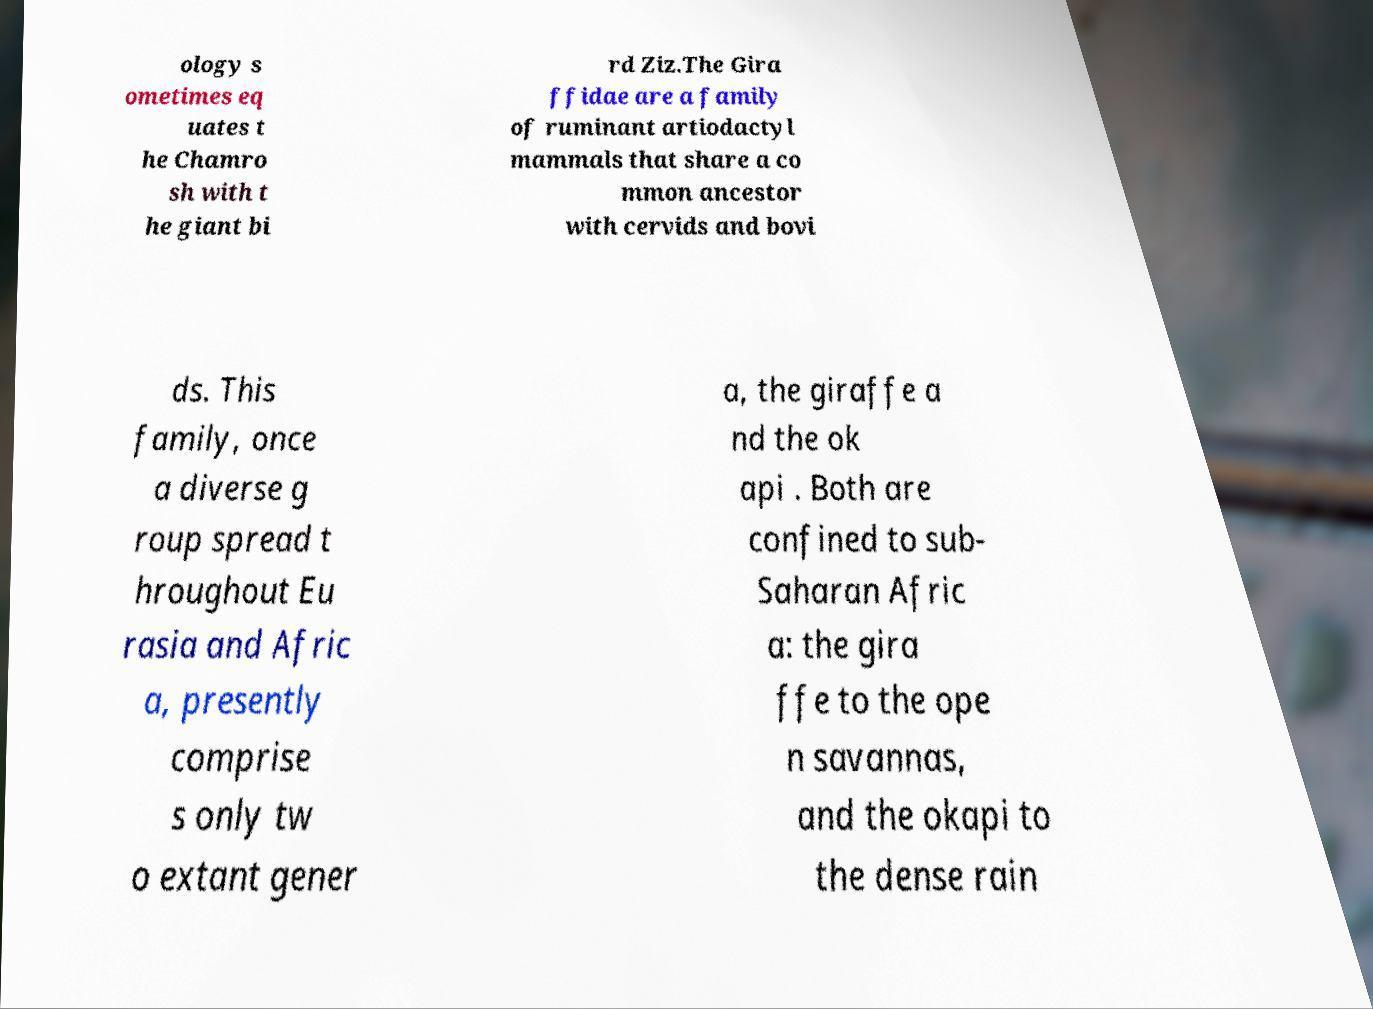I need the written content from this picture converted into text. Can you do that? ology s ometimes eq uates t he Chamro sh with t he giant bi rd Ziz.The Gira ffidae are a family of ruminant artiodactyl mammals that share a co mmon ancestor with cervids and bovi ds. This family, once a diverse g roup spread t hroughout Eu rasia and Afric a, presently comprise s only tw o extant gener a, the giraffe a nd the ok api . Both are confined to sub- Saharan Afric a: the gira ffe to the ope n savannas, and the okapi to the dense rain 